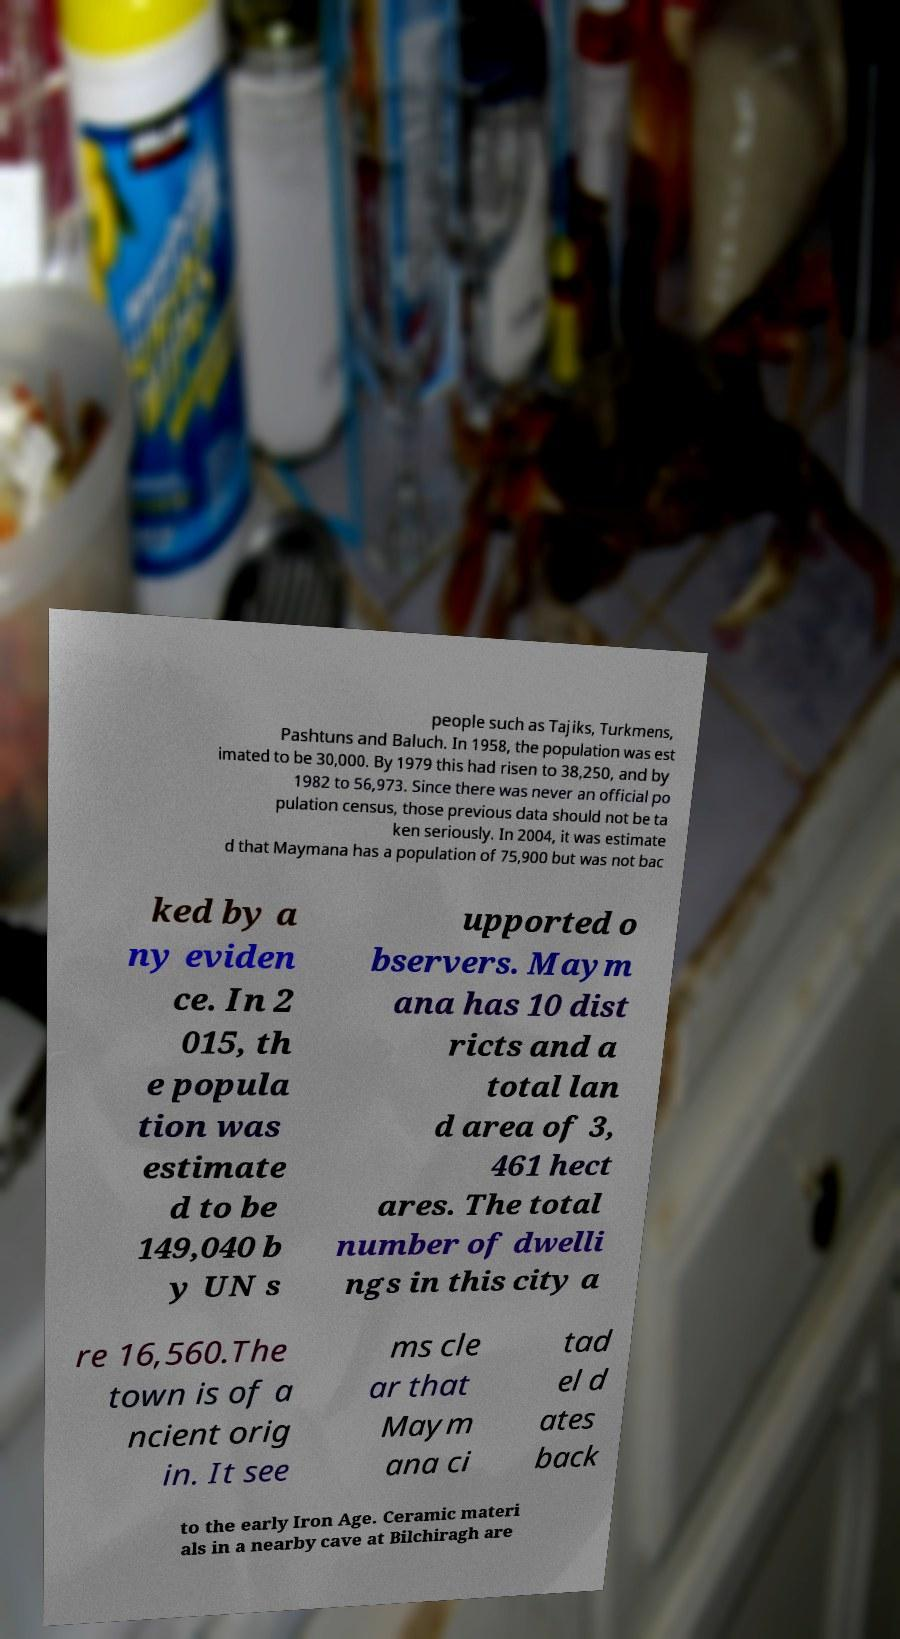Could you assist in decoding the text presented in this image and type it out clearly? people such as Tajiks, Turkmens, Pashtuns and Baluch. In 1958, the population was est imated to be 30,000. By 1979 this had risen to 38,250, and by 1982 to 56,973. Since there was never an official po pulation census, those previous data should not be ta ken seriously. In 2004, it was estimate d that Maymana has a population of 75,900 but was not bac ked by a ny eviden ce. In 2 015, th e popula tion was estimate d to be 149,040 b y UN s upported o bservers. Maym ana has 10 dist ricts and a total lan d area of 3, 461 hect ares. The total number of dwelli ngs in this city a re 16,560.The town is of a ncient orig in. It see ms cle ar that Maym ana ci tad el d ates back to the early Iron Age. Ceramic materi als in a nearby cave at Bilchiragh are 